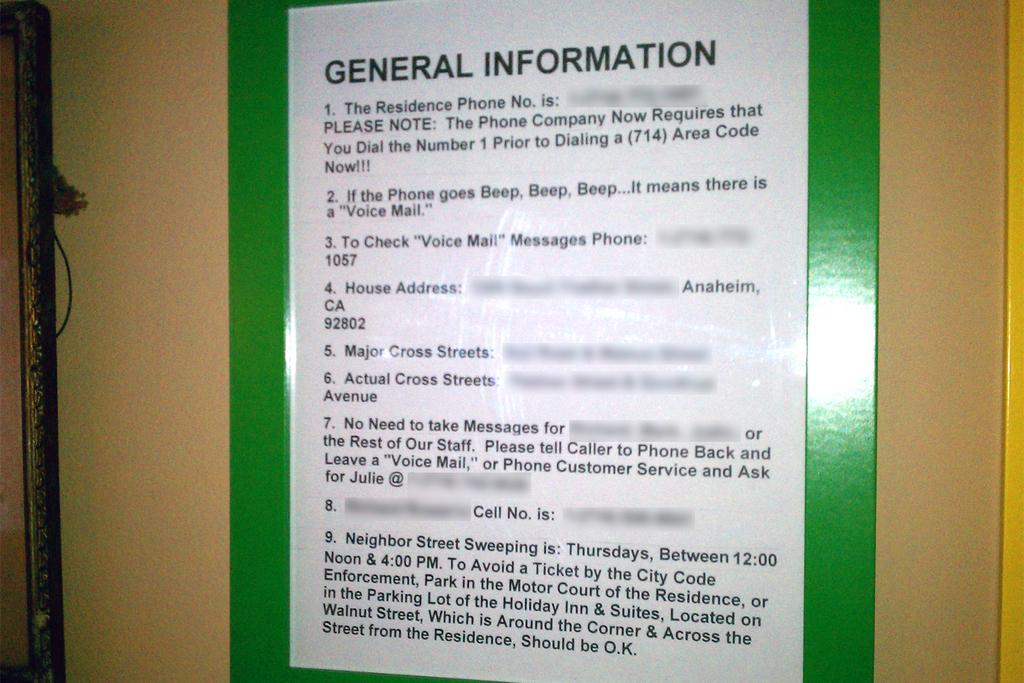<image>
Render a clear and concise summary of the photo. Note that is on a green poster hung on a wall that says General Information. 